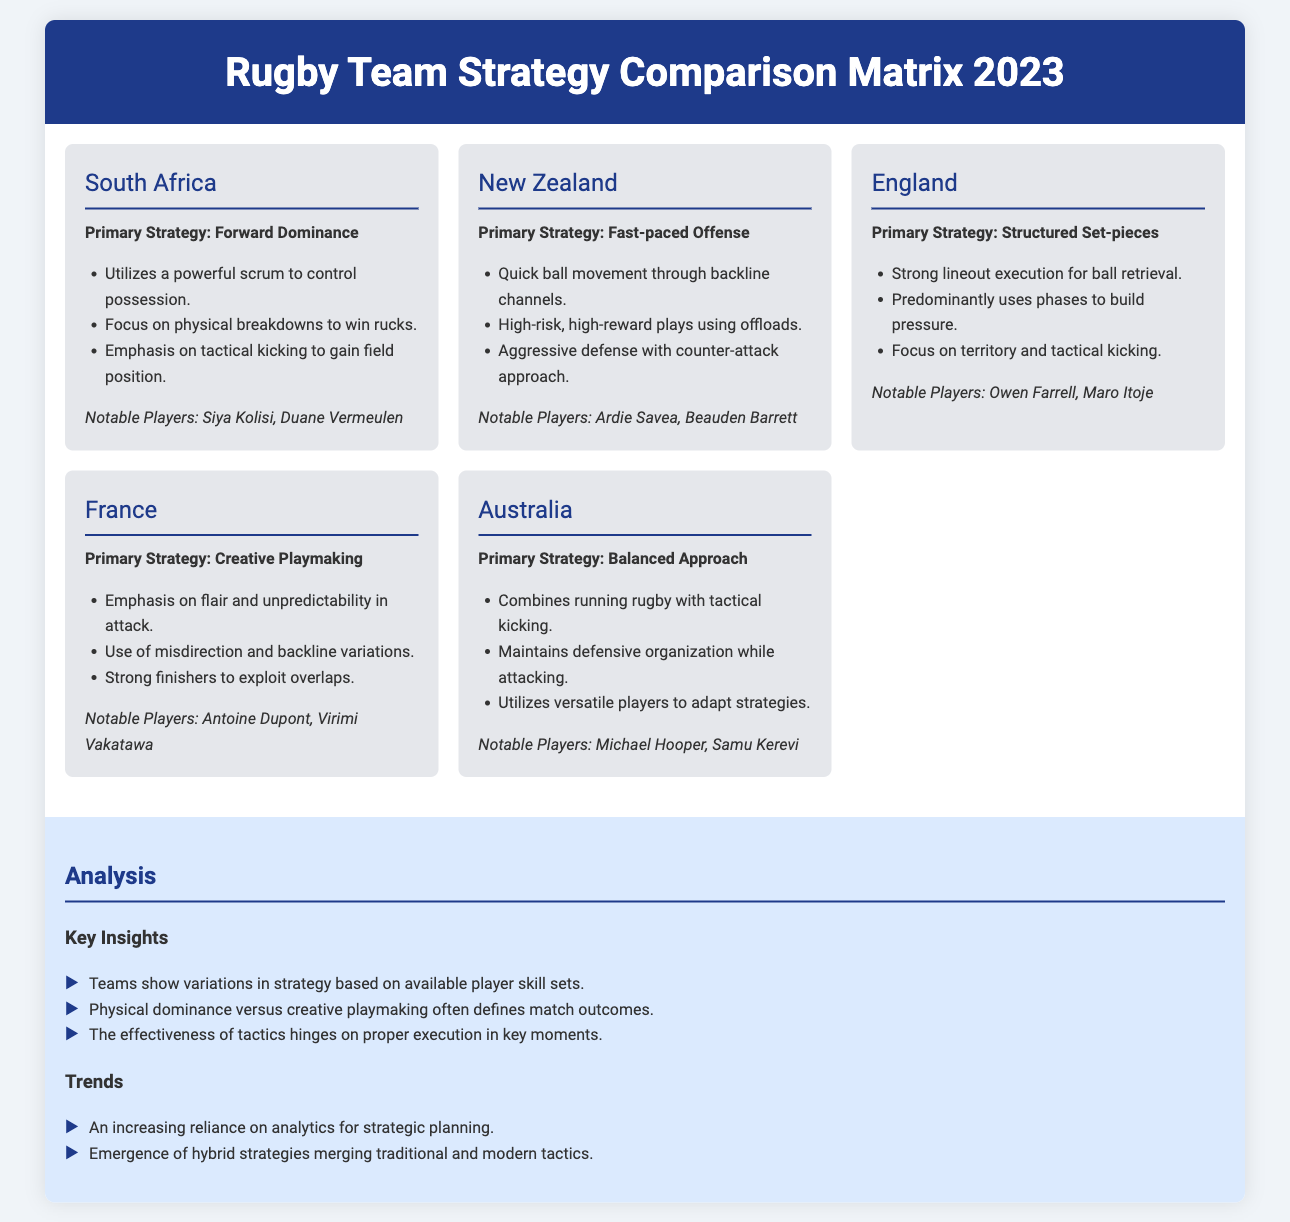what is the primary strategy of South Africa? The primary strategy of South Africa is Forward Dominance, which is stated in the document.
Answer: Forward Dominance who are the notable players from New Zealand? The document lists Ardie Savea and Beauden Barrett as notable players from New Zealand.
Answer: Ardie Savea, Beauden Barrett which team focuses on structured set-pieces? England is the team that primarily focuses on structured set-pieces, as indicated in the document.
Answer: England what type of offense does New Zealand employ? The document mentions that New Zealand employs a Fast-paced Offense.
Answer: Fast-paced Offense what is a key insight discussed in the analysis section? The document notes that teams show variations in strategy based on available player skill sets as a key insight.
Answer: Variations in strategy based on player skill sets how do Australia’s tactics combine? According to the document, Australia's tactics combine running rugby with tactical kicking.
Answer: Running rugby with tactical kicking what kind of plays does France emphasize? The document states that France emphasizes flair and unpredictability in attack.
Answer: Flair and unpredictability what is one trend observed in team strategies? An increasing reliance on analytics for strategic planning is noted as a trend in the analysis section.
Answer: Increasing reliance on analytics who is highlighted as a notable player for Australia? The document mentions Michael Hooper as a notable player for Australia.
Answer: Michael Hooper 